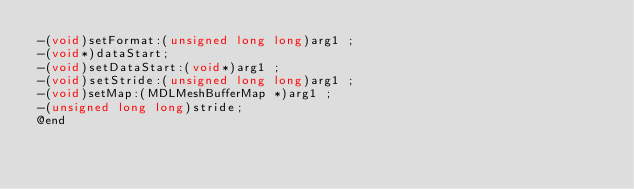Convert code to text. <code><loc_0><loc_0><loc_500><loc_500><_C_>-(void)setFormat:(unsigned long long)arg1 ;
-(void*)dataStart;
-(void)setDataStart:(void*)arg1 ;
-(void)setStride:(unsigned long long)arg1 ;
-(void)setMap:(MDLMeshBufferMap *)arg1 ;
-(unsigned long long)stride;
@end

</code> 